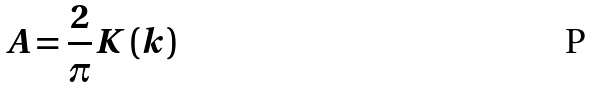<formula> <loc_0><loc_0><loc_500><loc_500>A = \frac { 2 } { \pi } K \left ( k \right )</formula> 